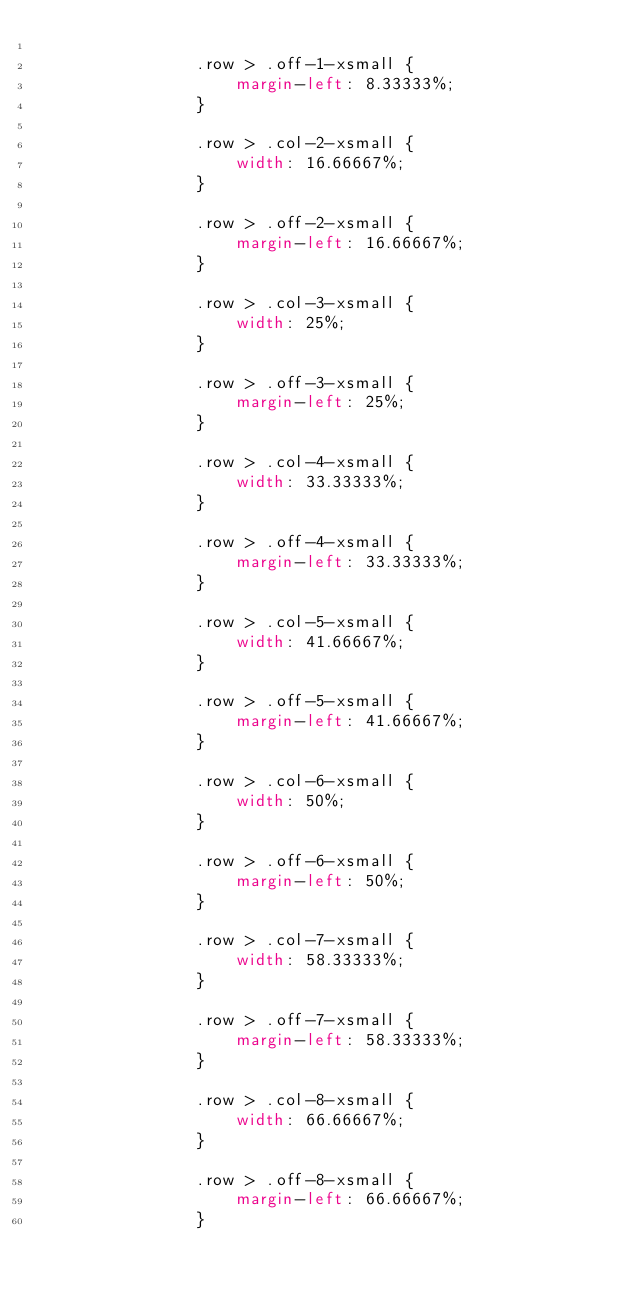<code> <loc_0><loc_0><loc_500><loc_500><_CSS_>
				.row > .off-1-xsmall {
					margin-left: 8.33333%;
				}

				.row > .col-2-xsmall {
					width: 16.66667%;
				}

				.row > .off-2-xsmall {
					margin-left: 16.66667%;
				}

				.row > .col-3-xsmall {
					width: 25%;
				}

				.row > .off-3-xsmall {
					margin-left: 25%;
				}

				.row > .col-4-xsmall {
					width: 33.33333%;
				}

				.row > .off-4-xsmall {
					margin-left: 33.33333%;
				}

				.row > .col-5-xsmall {
					width: 41.66667%;
				}

				.row > .off-5-xsmall {
					margin-left: 41.66667%;
				}

				.row > .col-6-xsmall {
					width: 50%;
				}

				.row > .off-6-xsmall {
					margin-left: 50%;
				}

				.row > .col-7-xsmall {
					width: 58.33333%;
				}

				.row > .off-7-xsmall {
					margin-left: 58.33333%;
				}

				.row > .col-8-xsmall {
					width: 66.66667%;
				}

				.row > .off-8-xsmall {
					margin-left: 66.66667%;
				}
</code> 